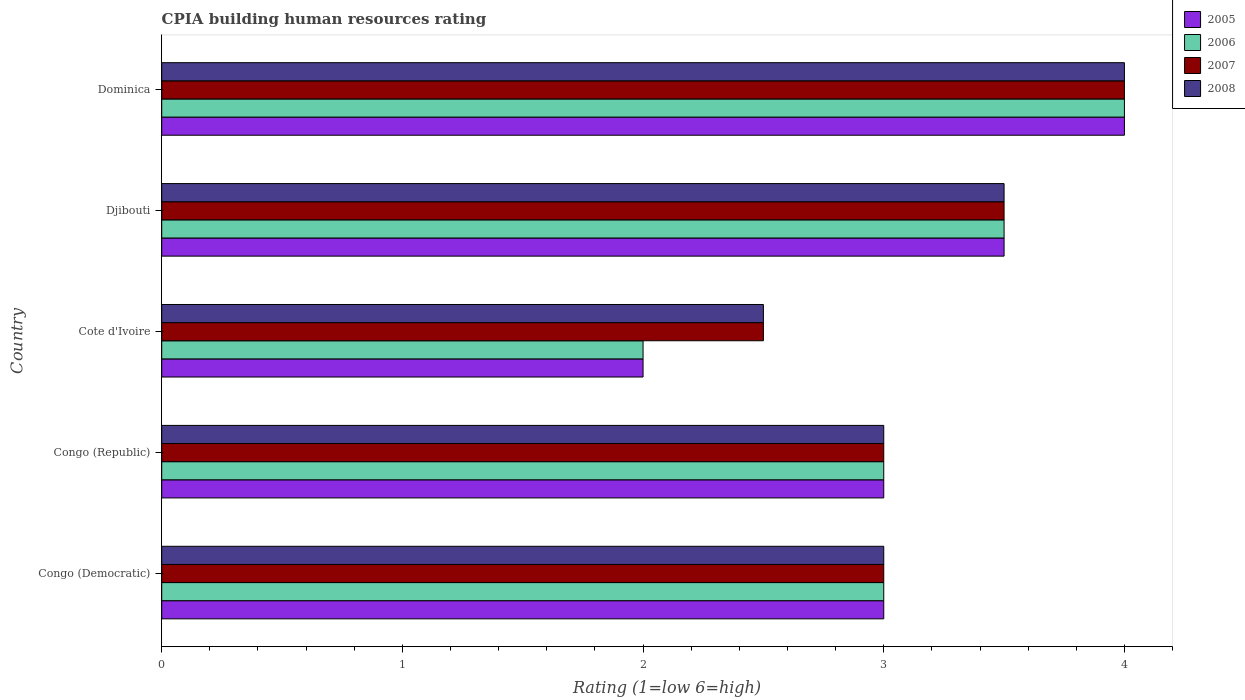Are the number of bars per tick equal to the number of legend labels?
Your answer should be compact. Yes. How many bars are there on the 1st tick from the bottom?
Provide a short and direct response. 4. What is the label of the 4th group of bars from the top?
Provide a short and direct response. Congo (Republic). Across all countries, what is the maximum CPIA rating in 2008?
Ensure brevity in your answer.  4. In which country was the CPIA rating in 2005 maximum?
Your response must be concise. Dominica. In which country was the CPIA rating in 2008 minimum?
Your response must be concise. Cote d'Ivoire. What is the total CPIA rating in 2007 in the graph?
Your answer should be very brief. 16. What is the difference between the CPIA rating in 2006 in Dominica and the CPIA rating in 2007 in Cote d'Ivoire?
Your answer should be very brief. 1.5. What is the ratio of the CPIA rating in 2007 in Congo (Republic) to that in Cote d'Ivoire?
Keep it short and to the point. 1.2. Is the CPIA rating in 2006 in Congo (Democratic) less than that in Djibouti?
Provide a succinct answer. Yes. Is the difference between the CPIA rating in 2007 in Congo (Democratic) and Djibouti greater than the difference between the CPIA rating in 2008 in Congo (Democratic) and Djibouti?
Provide a short and direct response. No. In how many countries, is the CPIA rating in 2006 greater than the average CPIA rating in 2006 taken over all countries?
Your response must be concise. 2. Is it the case that in every country, the sum of the CPIA rating in 2007 and CPIA rating in 2005 is greater than the sum of CPIA rating in 2006 and CPIA rating in 2008?
Provide a short and direct response. No. What does the 1st bar from the top in Dominica represents?
Make the answer very short. 2008. Is it the case that in every country, the sum of the CPIA rating in 2006 and CPIA rating in 2007 is greater than the CPIA rating in 2008?
Your answer should be very brief. Yes. How many countries are there in the graph?
Ensure brevity in your answer.  5. What is the difference between two consecutive major ticks on the X-axis?
Offer a very short reply. 1. Are the values on the major ticks of X-axis written in scientific E-notation?
Offer a terse response. No. Where does the legend appear in the graph?
Your answer should be very brief. Top right. How are the legend labels stacked?
Offer a very short reply. Vertical. What is the title of the graph?
Offer a terse response. CPIA building human resources rating. Does "1973" appear as one of the legend labels in the graph?
Your answer should be compact. No. What is the label or title of the X-axis?
Provide a short and direct response. Rating (1=low 6=high). What is the label or title of the Y-axis?
Offer a terse response. Country. What is the Rating (1=low 6=high) in 2005 in Congo (Democratic)?
Offer a very short reply. 3. What is the Rating (1=low 6=high) of 2007 in Congo (Democratic)?
Your answer should be compact. 3. What is the Rating (1=low 6=high) in 2006 in Congo (Republic)?
Your answer should be compact. 3. What is the Rating (1=low 6=high) in 2007 in Congo (Republic)?
Keep it short and to the point. 3. What is the Rating (1=low 6=high) of 2008 in Cote d'Ivoire?
Keep it short and to the point. 2.5. What is the Rating (1=low 6=high) in 2005 in Djibouti?
Provide a short and direct response. 3.5. What is the Rating (1=low 6=high) of 2006 in Dominica?
Give a very brief answer. 4. What is the Rating (1=low 6=high) of 2007 in Dominica?
Give a very brief answer. 4. What is the Rating (1=low 6=high) of 2008 in Dominica?
Provide a succinct answer. 4. Across all countries, what is the maximum Rating (1=low 6=high) in 2007?
Ensure brevity in your answer.  4. Across all countries, what is the minimum Rating (1=low 6=high) of 2005?
Give a very brief answer. 2. Across all countries, what is the minimum Rating (1=low 6=high) in 2006?
Ensure brevity in your answer.  2. Across all countries, what is the minimum Rating (1=low 6=high) in 2008?
Give a very brief answer. 2.5. What is the total Rating (1=low 6=high) of 2005 in the graph?
Offer a very short reply. 15.5. What is the total Rating (1=low 6=high) in 2006 in the graph?
Provide a succinct answer. 15.5. What is the total Rating (1=low 6=high) in 2008 in the graph?
Provide a short and direct response. 16. What is the difference between the Rating (1=low 6=high) in 2005 in Congo (Democratic) and that in Congo (Republic)?
Offer a very short reply. 0. What is the difference between the Rating (1=low 6=high) in 2006 in Congo (Democratic) and that in Congo (Republic)?
Give a very brief answer. 0. What is the difference between the Rating (1=low 6=high) in 2007 in Congo (Democratic) and that in Congo (Republic)?
Offer a very short reply. 0. What is the difference between the Rating (1=low 6=high) of 2008 in Congo (Democratic) and that in Congo (Republic)?
Give a very brief answer. 0. What is the difference between the Rating (1=low 6=high) in 2006 in Congo (Democratic) and that in Cote d'Ivoire?
Keep it short and to the point. 1. What is the difference between the Rating (1=low 6=high) of 2008 in Congo (Democratic) and that in Cote d'Ivoire?
Provide a short and direct response. 0.5. What is the difference between the Rating (1=low 6=high) in 2006 in Congo (Democratic) and that in Djibouti?
Your response must be concise. -0.5. What is the difference between the Rating (1=low 6=high) in 2007 in Congo (Democratic) and that in Djibouti?
Give a very brief answer. -0.5. What is the difference between the Rating (1=low 6=high) of 2008 in Congo (Democratic) and that in Djibouti?
Offer a terse response. -0.5. What is the difference between the Rating (1=low 6=high) in 2005 in Congo (Democratic) and that in Dominica?
Your answer should be very brief. -1. What is the difference between the Rating (1=low 6=high) of 2006 in Congo (Democratic) and that in Dominica?
Keep it short and to the point. -1. What is the difference between the Rating (1=low 6=high) of 2007 in Congo (Democratic) and that in Dominica?
Your answer should be compact. -1. What is the difference between the Rating (1=low 6=high) in 2005 in Congo (Republic) and that in Cote d'Ivoire?
Your answer should be compact. 1. What is the difference between the Rating (1=low 6=high) in 2006 in Congo (Republic) and that in Cote d'Ivoire?
Ensure brevity in your answer.  1. What is the difference between the Rating (1=low 6=high) in 2007 in Congo (Republic) and that in Cote d'Ivoire?
Your response must be concise. 0.5. What is the difference between the Rating (1=low 6=high) in 2006 in Congo (Republic) and that in Djibouti?
Provide a succinct answer. -0.5. What is the difference between the Rating (1=low 6=high) of 2007 in Congo (Republic) and that in Dominica?
Your answer should be compact. -1. What is the difference between the Rating (1=low 6=high) of 2008 in Congo (Republic) and that in Dominica?
Your response must be concise. -1. What is the difference between the Rating (1=low 6=high) of 2005 in Cote d'Ivoire and that in Djibouti?
Give a very brief answer. -1.5. What is the difference between the Rating (1=low 6=high) of 2006 in Djibouti and that in Dominica?
Provide a succinct answer. -0.5. What is the difference between the Rating (1=low 6=high) of 2008 in Djibouti and that in Dominica?
Ensure brevity in your answer.  -0.5. What is the difference between the Rating (1=low 6=high) of 2005 in Congo (Democratic) and the Rating (1=low 6=high) of 2007 in Congo (Republic)?
Make the answer very short. 0. What is the difference between the Rating (1=low 6=high) in 2005 in Congo (Democratic) and the Rating (1=low 6=high) in 2008 in Congo (Republic)?
Ensure brevity in your answer.  0. What is the difference between the Rating (1=low 6=high) in 2006 in Congo (Democratic) and the Rating (1=low 6=high) in 2007 in Congo (Republic)?
Provide a succinct answer. 0. What is the difference between the Rating (1=low 6=high) in 2006 in Congo (Democratic) and the Rating (1=low 6=high) in 2008 in Congo (Republic)?
Provide a short and direct response. 0. What is the difference between the Rating (1=low 6=high) in 2007 in Congo (Democratic) and the Rating (1=low 6=high) in 2008 in Cote d'Ivoire?
Provide a short and direct response. 0.5. What is the difference between the Rating (1=low 6=high) of 2006 in Congo (Democratic) and the Rating (1=low 6=high) of 2007 in Djibouti?
Your response must be concise. -0.5. What is the difference between the Rating (1=low 6=high) of 2005 in Congo (Democratic) and the Rating (1=low 6=high) of 2006 in Dominica?
Offer a terse response. -1. What is the difference between the Rating (1=low 6=high) of 2005 in Congo (Democratic) and the Rating (1=low 6=high) of 2008 in Dominica?
Provide a short and direct response. -1. What is the difference between the Rating (1=low 6=high) of 2006 in Congo (Democratic) and the Rating (1=low 6=high) of 2007 in Dominica?
Your answer should be very brief. -1. What is the difference between the Rating (1=low 6=high) of 2006 in Congo (Democratic) and the Rating (1=low 6=high) of 2008 in Dominica?
Your response must be concise. -1. What is the difference between the Rating (1=low 6=high) of 2007 in Congo (Democratic) and the Rating (1=low 6=high) of 2008 in Dominica?
Offer a terse response. -1. What is the difference between the Rating (1=low 6=high) of 2005 in Congo (Republic) and the Rating (1=low 6=high) of 2006 in Cote d'Ivoire?
Your answer should be compact. 1. What is the difference between the Rating (1=low 6=high) in 2005 in Congo (Republic) and the Rating (1=low 6=high) in 2007 in Cote d'Ivoire?
Make the answer very short. 0.5. What is the difference between the Rating (1=low 6=high) in 2005 in Congo (Republic) and the Rating (1=low 6=high) in 2007 in Djibouti?
Provide a short and direct response. -0.5. What is the difference between the Rating (1=low 6=high) in 2005 in Congo (Republic) and the Rating (1=low 6=high) in 2008 in Djibouti?
Your response must be concise. -0.5. What is the difference between the Rating (1=low 6=high) of 2005 in Congo (Republic) and the Rating (1=low 6=high) of 2006 in Dominica?
Make the answer very short. -1. What is the difference between the Rating (1=low 6=high) in 2006 in Congo (Republic) and the Rating (1=low 6=high) in 2007 in Dominica?
Provide a short and direct response. -1. What is the difference between the Rating (1=low 6=high) in 2007 in Congo (Republic) and the Rating (1=low 6=high) in 2008 in Dominica?
Offer a very short reply. -1. What is the difference between the Rating (1=low 6=high) of 2005 in Cote d'Ivoire and the Rating (1=low 6=high) of 2007 in Djibouti?
Make the answer very short. -1.5. What is the difference between the Rating (1=low 6=high) of 2005 in Cote d'Ivoire and the Rating (1=low 6=high) of 2008 in Djibouti?
Make the answer very short. -1.5. What is the difference between the Rating (1=low 6=high) in 2006 in Cote d'Ivoire and the Rating (1=low 6=high) in 2008 in Djibouti?
Make the answer very short. -1.5. What is the difference between the Rating (1=low 6=high) in 2007 in Cote d'Ivoire and the Rating (1=low 6=high) in 2008 in Djibouti?
Your answer should be very brief. -1. What is the difference between the Rating (1=low 6=high) of 2005 in Cote d'Ivoire and the Rating (1=low 6=high) of 2006 in Dominica?
Keep it short and to the point. -2. What is the difference between the Rating (1=low 6=high) of 2005 in Cote d'Ivoire and the Rating (1=low 6=high) of 2007 in Dominica?
Keep it short and to the point. -2. What is the difference between the Rating (1=low 6=high) in 2005 in Cote d'Ivoire and the Rating (1=low 6=high) in 2008 in Dominica?
Provide a short and direct response. -2. What is the difference between the Rating (1=low 6=high) in 2006 in Cote d'Ivoire and the Rating (1=low 6=high) in 2007 in Dominica?
Keep it short and to the point. -2. What is the difference between the Rating (1=low 6=high) in 2006 in Cote d'Ivoire and the Rating (1=low 6=high) in 2008 in Dominica?
Provide a succinct answer. -2. What is the difference between the Rating (1=low 6=high) of 2005 in Djibouti and the Rating (1=low 6=high) of 2007 in Dominica?
Your response must be concise. -0.5. What is the difference between the Rating (1=low 6=high) in 2005 in Djibouti and the Rating (1=low 6=high) in 2008 in Dominica?
Ensure brevity in your answer.  -0.5. What is the difference between the Rating (1=low 6=high) of 2006 in Djibouti and the Rating (1=low 6=high) of 2007 in Dominica?
Provide a succinct answer. -0.5. What is the difference between the Rating (1=low 6=high) of 2007 in Djibouti and the Rating (1=low 6=high) of 2008 in Dominica?
Provide a succinct answer. -0.5. What is the average Rating (1=low 6=high) in 2006 per country?
Make the answer very short. 3.1. What is the average Rating (1=low 6=high) in 2007 per country?
Offer a terse response. 3.2. What is the average Rating (1=low 6=high) in 2008 per country?
Offer a terse response. 3.2. What is the difference between the Rating (1=low 6=high) in 2006 and Rating (1=low 6=high) in 2008 in Congo (Democratic)?
Offer a terse response. 0. What is the difference between the Rating (1=low 6=high) of 2007 and Rating (1=low 6=high) of 2008 in Congo (Democratic)?
Provide a succinct answer. 0. What is the difference between the Rating (1=low 6=high) in 2005 and Rating (1=low 6=high) in 2006 in Congo (Republic)?
Provide a short and direct response. 0. What is the difference between the Rating (1=low 6=high) of 2006 and Rating (1=low 6=high) of 2008 in Congo (Republic)?
Your response must be concise. 0. What is the difference between the Rating (1=low 6=high) of 2007 and Rating (1=low 6=high) of 2008 in Congo (Republic)?
Make the answer very short. 0. What is the difference between the Rating (1=low 6=high) in 2005 and Rating (1=low 6=high) in 2006 in Cote d'Ivoire?
Ensure brevity in your answer.  0. What is the difference between the Rating (1=low 6=high) of 2005 and Rating (1=low 6=high) of 2007 in Djibouti?
Your response must be concise. 0. What is the difference between the Rating (1=low 6=high) in 2005 and Rating (1=low 6=high) in 2008 in Djibouti?
Your response must be concise. 0. What is the difference between the Rating (1=low 6=high) in 2006 and Rating (1=low 6=high) in 2007 in Djibouti?
Give a very brief answer. 0. What is the difference between the Rating (1=low 6=high) in 2006 and Rating (1=low 6=high) in 2008 in Djibouti?
Your answer should be very brief. 0. What is the difference between the Rating (1=low 6=high) of 2007 and Rating (1=low 6=high) of 2008 in Djibouti?
Make the answer very short. 0. What is the difference between the Rating (1=low 6=high) of 2005 and Rating (1=low 6=high) of 2006 in Dominica?
Provide a short and direct response. 0. What is the difference between the Rating (1=low 6=high) of 2005 and Rating (1=low 6=high) of 2007 in Dominica?
Give a very brief answer. 0. What is the difference between the Rating (1=low 6=high) in 2005 and Rating (1=low 6=high) in 2008 in Dominica?
Make the answer very short. 0. What is the ratio of the Rating (1=low 6=high) of 2005 in Congo (Democratic) to that in Congo (Republic)?
Give a very brief answer. 1. What is the ratio of the Rating (1=low 6=high) of 2008 in Congo (Democratic) to that in Congo (Republic)?
Ensure brevity in your answer.  1. What is the ratio of the Rating (1=low 6=high) in 2005 in Congo (Democratic) to that in Cote d'Ivoire?
Offer a terse response. 1.5. What is the ratio of the Rating (1=low 6=high) in 2006 in Congo (Democratic) to that in Djibouti?
Your answer should be very brief. 0.86. What is the ratio of the Rating (1=low 6=high) of 2007 in Congo (Democratic) to that in Djibouti?
Offer a very short reply. 0.86. What is the ratio of the Rating (1=low 6=high) of 2005 in Congo (Democratic) to that in Dominica?
Your answer should be very brief. 0.75. What is the ratio of the Rating (1=low 6=high) in 2007 in Congo (Democratic) to that in Dominica?
Your answer should be compact. 0.75. What is the ratio of the Rating (1=low 6=high) in 2008 in Congo (Democratic) to that in Dominica?
Provide a short and direct response. 0.75. What is the ratio of the Rating (1=low 6=high) in 2006 in Congo (Republic) to that in Cote d'Ivoire?
Offer a very short reply. 1.5. What is the ratio of the Rating (1=low 6=high) of 2005 in Congo (Republic) to that in Djibouti?
Keep it short and to the point. 0.86. What is the ratio of the Rating (1=low 6=high) of 2006 in Congo (Republic) to that in Djibouti?
Provide a short and direct response. 0.86. What is the ratio of the Rating (1=low 6=high) in 2007 in Congo (Republic) to that in Dominica?
Ensure brevity in your answer.  0.75. What is the ratio of the Rating (1=low 6=high) in 2005 in Cote d'Ivoire to that in Djibouti?
Provide a short and direct response. 0.57. What is the ratio of the Rating (1=low 6=high) of 2007 in Cote d'Ivoire to that in Djibouti?
Keep it short and to the point. 0.71. What is the ratio of the Rating (1=low 6=high) of 2008 in Cote d'Ivoire to that in Djibouti?
Provide a short and direct response. 0.71. What is the ratio of the Rating (1=low 6=high) in 2008 in Cote d'Ivoire to that in Dominica?
Provide a succinct answer. 0.62. What is the ratio of the Rating (1=low 6=high) of 2007 in Djibouti to that in Dominica?
Provide a short and direct response. 0.88. What is the difference between the highest and the second highest Rating (1=low 6=high) of 2007?
Keep it short and to the point. 0.5. What is the difference between the highest and the second highest Rating (1=low 6=high) in 2008?
Your answer should be compact. 0.5. What is the difference between the highest and the lowest Rating (1=low 6=high) of 2005?
Keep it short and to the point. 2. What is the difference between the highest and the lowest Rating (1=low 6=high) of 2006?
Keep it short and to the point. 2. What is the difference between the highest and the lowest Rating (1=low 6=high) of 2007?
Keep it short and to the point. 1.5. What is the difference between the highest and the lowest Rating (1=low 6=high) in 2008?
Offer a very short reply. 1.5. 